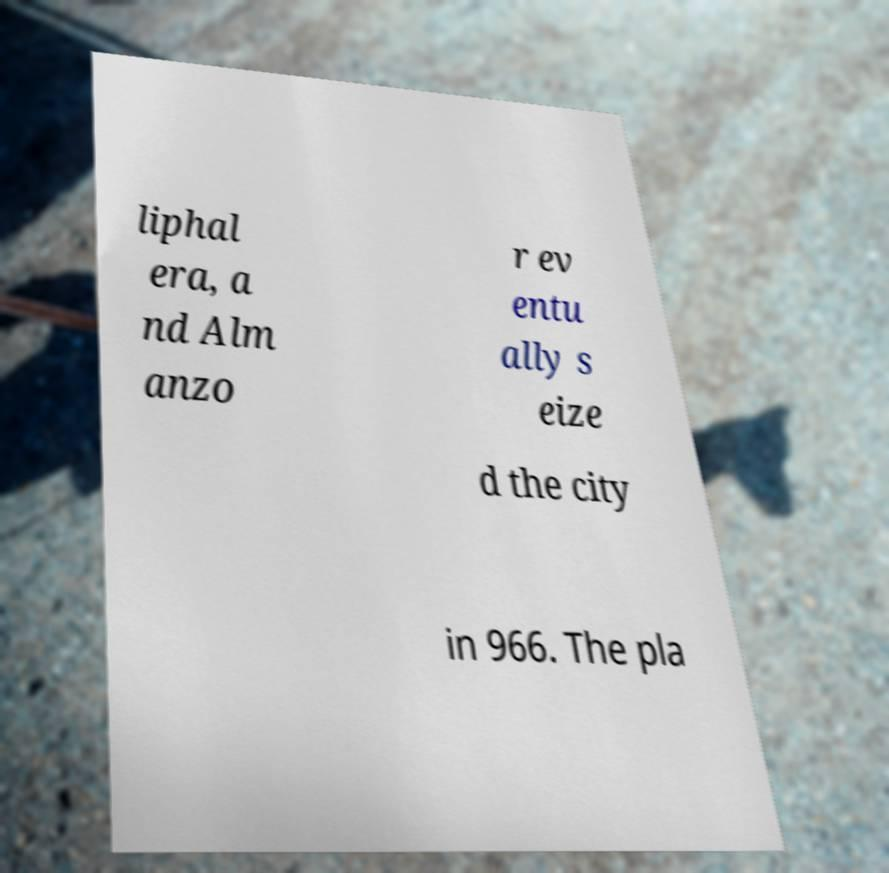Can you read and provide the text displayed in the image?This photo seems to have some interesting text. Can you extract and type it out for me? liphal era, a nd Alm anzo r ev entu ally s eize d the city in 966. The pla 